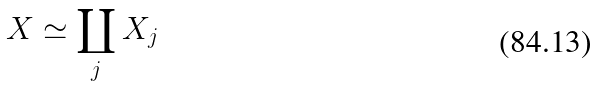<formula> <loc_0><loc_0><loc_500><loc_500>X \simeq \coprod _ { j } X _ { j }</formula> 